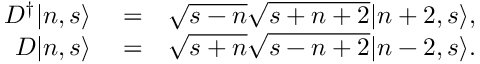Convert formula to latex. <formula><loc_0><loc_0><loc_500><loc_500>\begin{array} { r l r } { D ^ { \dagger } | n , s \rangle } & = } & { \sqrt { s - n } \sqrt { s + n + 2 } | n + 2 , s \rangle , } \\ { D | n , s \rangle } & = } & { \sqrt { s + n } \sqrt { s - n + 2 } | n - 2 , s \rangle . } \end{array}</formula> 